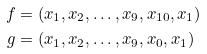<formula> <loc_0><loc_0><loc_500><loc_500>f & = ( x _ { 1 } , x _ { 2 } , \dots , x _ { 9 } , x _ { 1 0 } , x _ { 1 } ) \\ g & = ( x _ { 1 } , x _ { 2 } , \dots , x _ { 9 } , x _ { 0 } , x _ { 1 } )</formula> 